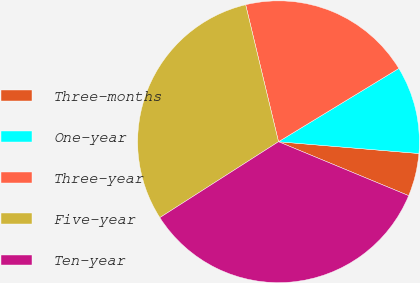Convert chart to OTSL. <chart><loc_0><loc_0><loc_500><loc_500><pie_chart><fcel>Three-months<fcel>One-year<fcel>Three-year<fcel>Five-year<fcel>Ten-year<nl><fcel>4.92%<fcel>10.04%<fcel>20.04%<fcel>30.31%<fcel>34.69%<nl></chart> 